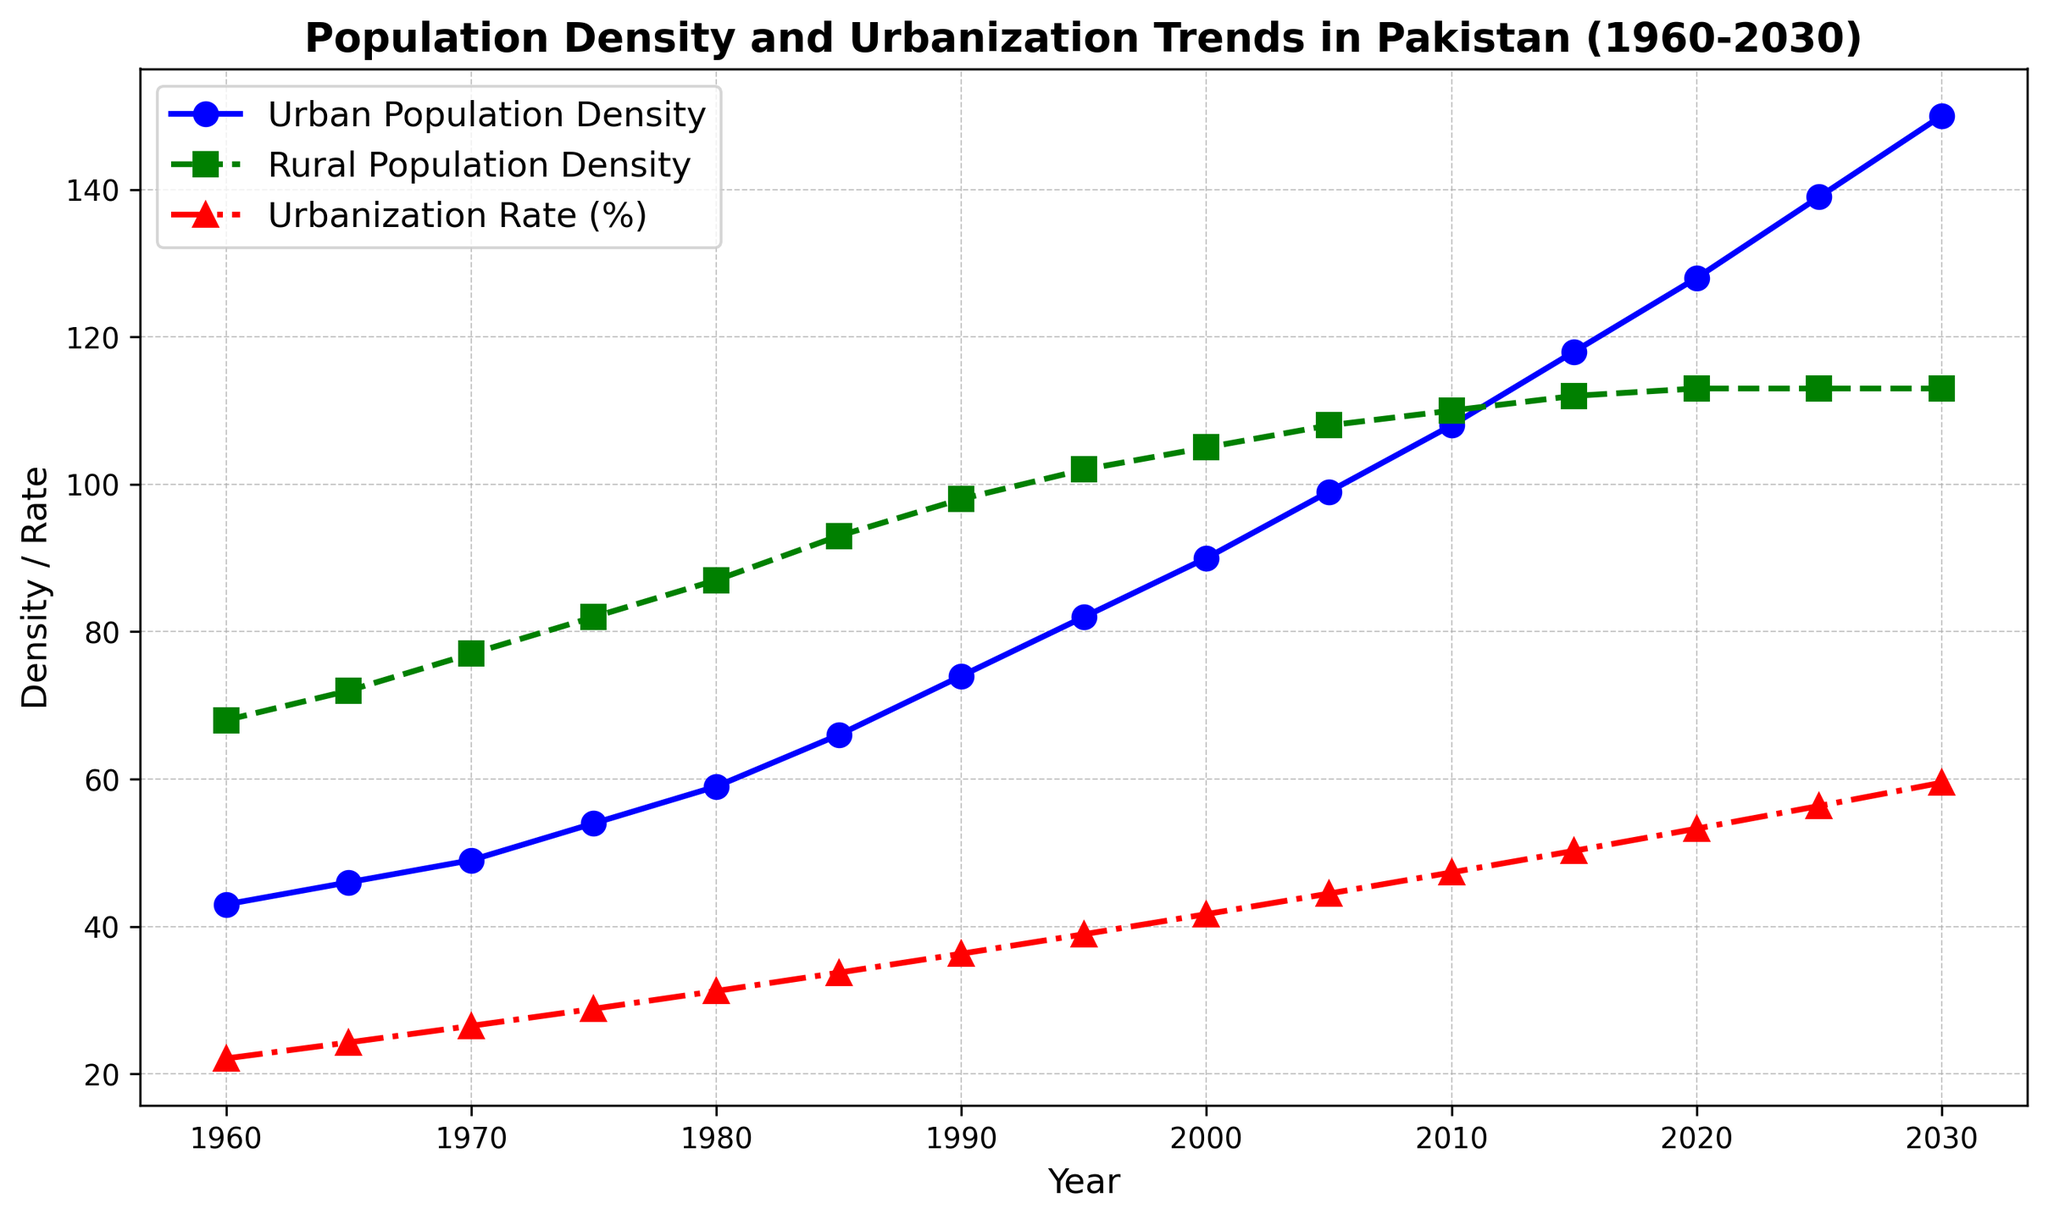What is the urban population density in the year 2000? Refer to the blue line on the plot indicating urban population density. At the year 2000, the blue line shows a value of 90.
Answer: 90 What is the difference between urban and rural population density in 1995? Check the values for urban and rural population densities in 1995 from the respective lines. Urban population density in 1995 is 82, and rural is 102. The difference is 102 - 82.
Answer: 20 How has the urbanization rate changed from 1960 to 2030? From the red line representing the urbanization rate, observe the values at 1960 and 2030. In 1960, it is 22.10%, and in 2030, it is 59.52%. The change is 59.52% - 22.10%.
Answer: 37.42% Which year sees the urban population density surpass 100? Follow the blue line for urban population density and identify the first year it goes above 100. The line crosses 100 between 2005 and 2010, with the value in 2010 being above 100.
Answer: 2010 What is the average urbanization rate from 1960 to 2020? Sum the urbanization rates from 1960 to 2020 and divide by the number of years (61 years). (22.10 + 24.27 + 26.52 + 28.84 + 31.25 + 33.74 + 36.31 + 38.95 + 41.68 + 44.47 + 47.34 + 50.27 + 53.28) / 13 = 38.92.
Answer: 38.92% During which decade did urban population density grow the most? By observing the blue line, find the decade with the steepest increase. Compare the increments: 1960-1970 (49-43=6), 1970-1980 (59-49=10), 1980-1990 (74-59=15), 1990-2000 (90-74=16), 2000-2010 (108-90=18). The largest increase is between 2000 and 2010.
Answer: 2000-2010 In which year do rural and urban population densities start to have a smaller difference and remain close afterward? Review the plot where the gap between the green line (rural) and blue line (urban) starts reducing permanently, which notably happens around 2020.
Answer: 2020 What year shows an urbanization rate of around 50%? Observe the red line and identify the year when it reaches near 50%. The year closest to 50% is 2015.
Answer: 2015 